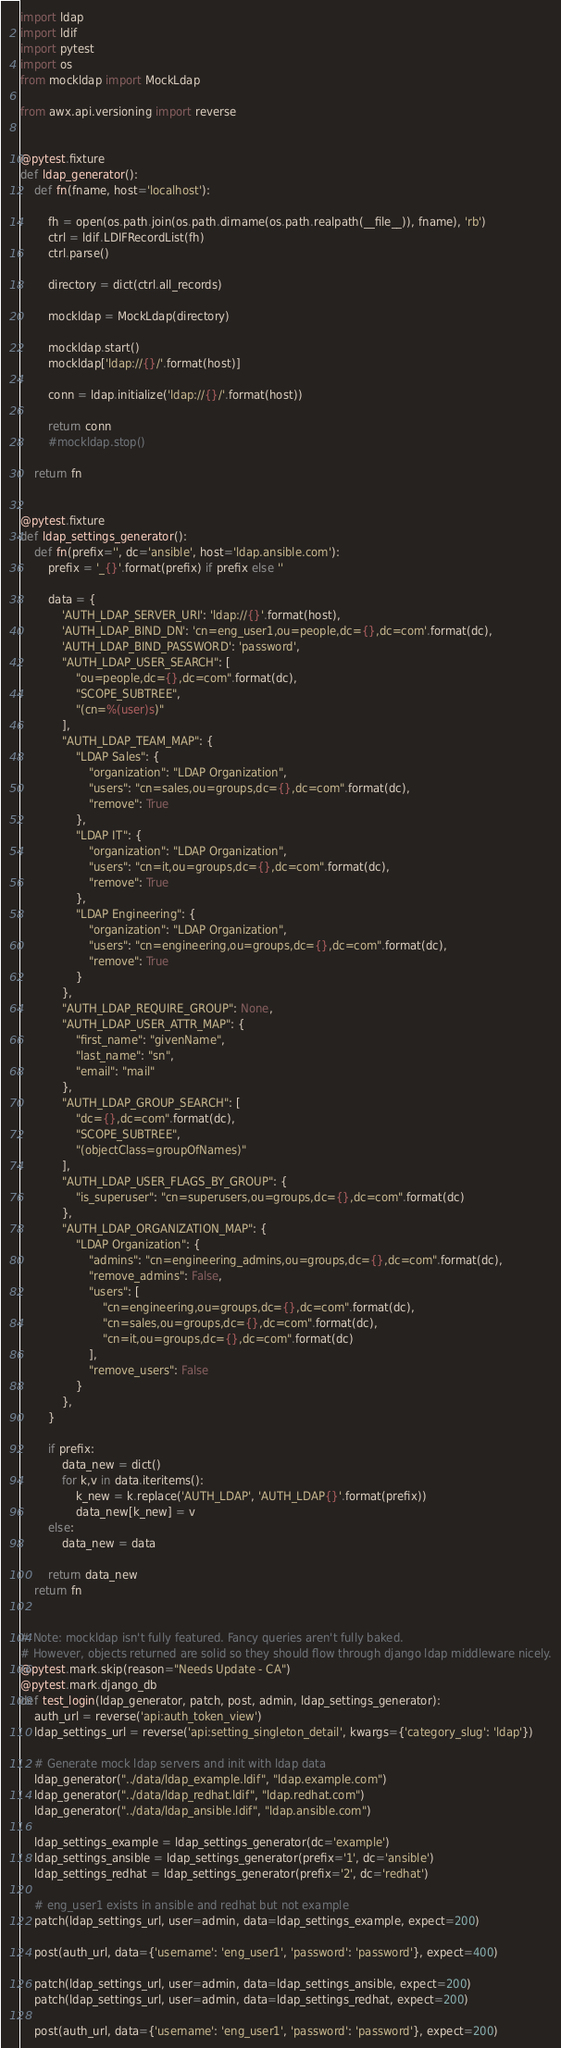Convert code to text. <code><loc_0><loc_0><loc_500><loc_500><_Python_>
import ldap
import ldif
import pytest
import os
from mockldap import MockLdap

from awx.api.versioning import reverse


@pytest.fixture
def ldap_generator():
    def fn(fname, host='localhost'):

        fh = open(os.path.join(os.path.dirname(os.path.realpath(__file__)), fname), 'rb')
        ctrl = ldif.LDIFRecordList(fh)
        ctrl.parse()

        directory = dict(ctrl.all_records)

        mockldap = MockLdap(directory)

        mockldap.start()
        mockldap['ldap://{}/'.format(host)]

        conn = ldap.initialize('ldap://{}/'.format(host))

        return conn
        #mockldap.stop()

    return fn


@pytest.fixture
def ldap_settings_generator():
    def fn(prefix='', dc='ansible', host='ldap.ansible.com'):
        prefix = '_{}'.format(prefix) if prefix else ''

        data = {
            'AUTH_LDAP_SERVER_URI': 'ldap://{}'.format(host),
            'AUTH_LDAP_BIND_DN': 'cn=eng_user1,ou=people,dc={},dc=com'.format(dc),
            'AUTH_LDAP_BIND_PASSWORD': 'password',
            "AUTH_LDAP_USER_SEARCH": [
                "ou=people,dc={},dc=com".format(dc),
                "SCOPE_SUBTREE",
                "(cn=%(user)s)"
            ],
            "AUTH_LDAP_TEAM_MAP": {
                "LDAP Sales": {
                    "organization": "LDAP Organization",
                    "users": "cn=sales,ou=groups,dc={},dc=com".format(dc),
                    "remove": True
                },
                "LDAP IT": {
                    "organization": "LDAP Organization",
                    "users": "cn=it,ou=groups,dc={},dc=com".format(dc),
                    "remove": True
                },
                "LDAP Engineering": {
                    "organization": "LDAP Organization",
                    "users": "cn=engineering,ou=groups,dc={},dc=com".format(dc),
                    "remove": True
                }
            },
            "AUTH_LDAP_REQUIRE_GROUP": None,
            "AUTH_LDAP_USER_ATTR_MAP": {
                "first_name": "givenName",
                "last_name": "sn",
                "email": "mail"
            },
            "AUTH_LDAP_GROUP_SEARCH": [
                "dc={},dc=com".format(dc),
                "SCOPE_SUBTREE",
                "(objectClass=groupOfNames)"
            ],
            "AUTH_LDAP_USER_FLAGS_BY_GROUP": {
                "is_superuser": "cn=superusers,ou=groups,dc={},dc=com".format(dc)
            },
            "AUTH_LDAP_ORGANIZATION_MAP": {
                "LDAP Organization": {
                    "admins": "cn=engineering_admins,ou=groups,dc={},dc=com".format(dc),
                    "remove_admins": False,
                    "users": [
                        "cn=engineering,ou=groups,dc={},dc=com".format(dc),
                        "cn=sales,ou=groups,dc={},dc=com".format(dc),
                        "cn=it,ou=groups,dc={},dc=com".format(dc)
                    ],
                    "remove_users": False
                }
            },
        }

        if prefix:
            data_new = dict()
            for k,v in data.iteritems():
                k_new = k.replace('AUTH_LDAP', 'AUTH_LDAP{}'.format(prefix))
                data_new[k_new] = v
        else:
            data_new = data

        return data_new
    return fn


# Note: mockldap isn't fully featured. Fancy queries aren't fully baked.
# However, objects returned are solid so they should flow through django ldap middleware nicely.
@pytest.mark.skip(reason="Needs Update - CA")
@pytest.mark.django_db
def test_login(ldap_generator, patch, post, admin, ldap_settings_generator):
    auth_url = reverse('api:auth_token_view')
    ldap_settings_url = reverse('api:setting_singleton_detail', kwargs={'category_slug': 'ldap'})

    # Generate mock ldap servers and init with ldap data
    ldap_generator("../data/ldap_example.ldif", "ldap.example.com")
    ldap_generator("../data/ldap_redhat.ldif", "ldap.redhat.com")
    ldap_generator("../data/ldap_ansible.ldif", "ldap.ansible.com")

    ldap_settings_example = ldap_settings_generator(dc='example')
    ldap_settings_ansible = ldap_settings_generator(prefix='1', dc='ansible')
    ldap_settings_redhat = ldap_settings_generator(prefix='2', dc='redhat')

    # eng_user1 exists in ansible and redhat but not example
    patch(ldap_settings_url, user=admin, data=ldap_settings_example, expect=200)

    post(auth_url, data={'username': 'eng_user1', 'password': 'password'}, expect=400)

    patch(ldap_settings_url, user=admin, data=ldap_settings_ansible, expect=200)
    patch(ldap_settings_url, user=admin, data=ldap_settings_redhat, expect=200)

    post(auth_url, data={'username': 'eng_user1', 'password': 'password'}, expect=200)

</code> 